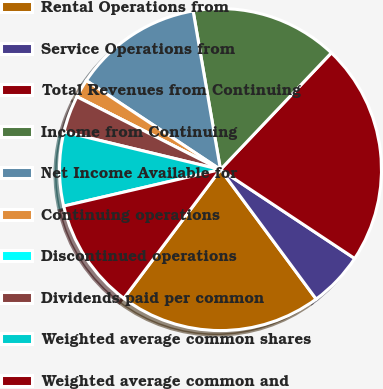Convert chart. <chart><loc_0><loc_0><loc_500><loc_500><pie_chart><fcel>Rental Operations from<fcel>Service Operations from<fcel>Total Revenues from Continuing<fcel>Income from Continuing<fcel>Net Income Available for<fcel>Continuing operations<fcel>Discontinued operations<fcel>Dividends paid per common<fcel>Weighted average common shares<fcel>Weighted average common and<nl><fcel>20.37%<fcel>5.56%<fcel>22.22%<fcel>14.81%<fcel>12.96%<fcel>1.85%<fcel>0.0%<fcel>3.7%<fcel>7.41%<fcel>11.11%<nl></chart> 